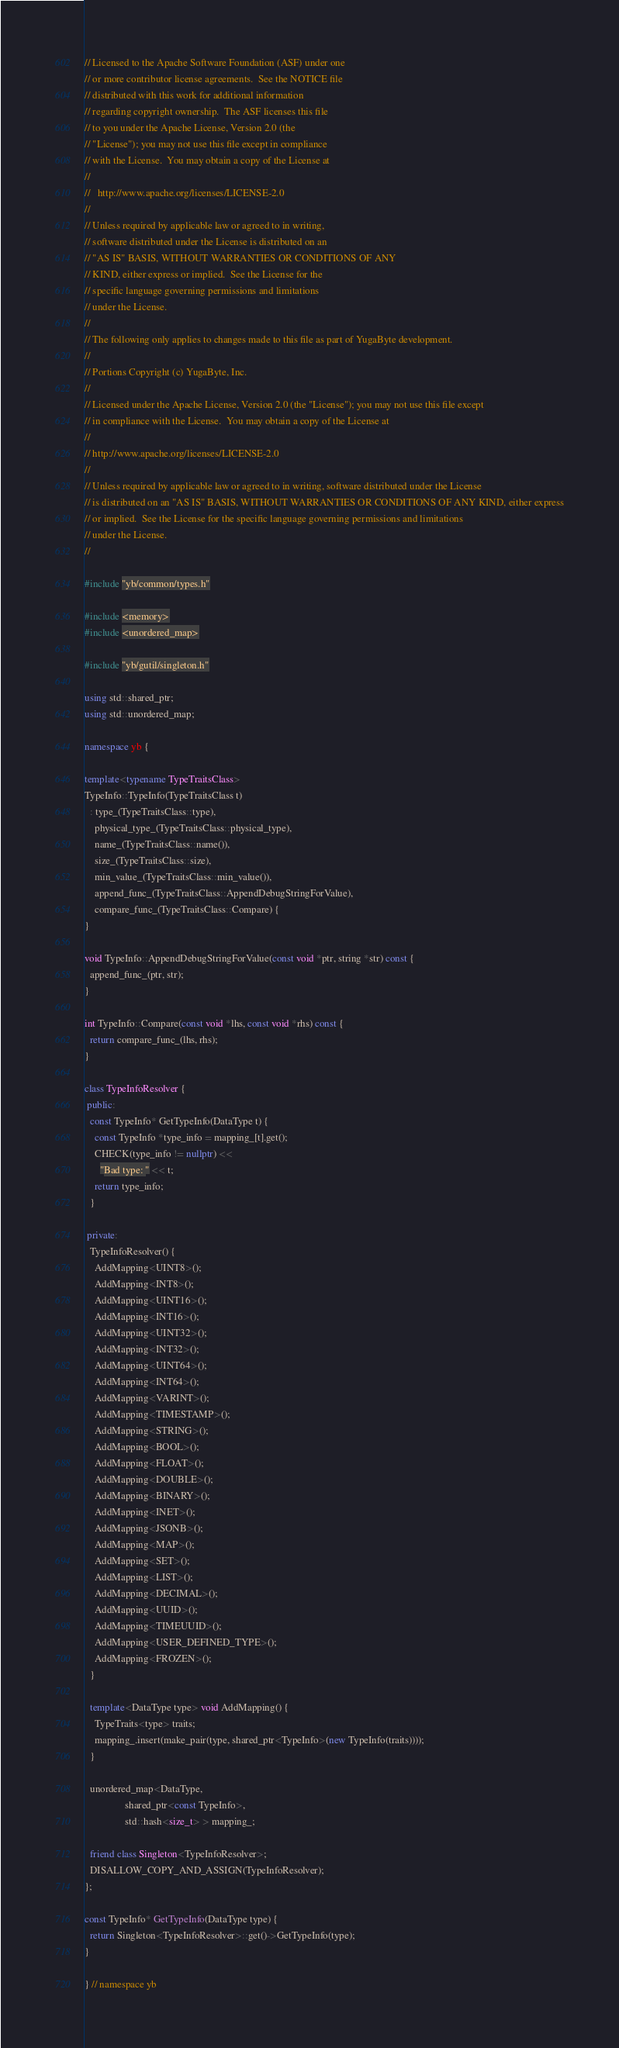<code> <loc_0><loc_0><loc_500><loc_500><_C++_>// Licensed to the Apache Software Foundation (ASF) under one
// or more contributor license agreements.  See the NOTICE file
// distributed with this work for additional information
// regarding copyright ownership.  The ASF licenses this file
// to you under the Apache License, Version 2.0 (the
// "License"); you may not use this file except in compliance
// with the License.  You may obtain a copy of the License at
//
//   http://www.apache.org/licenses/LICENSE-2.0
//
// Unless required by applicable law or agreed to in writing,
// software distributed under the License is distributed on an
// "AS IS" BASIS, WITHOUT WARRANTIES OR CONDITIONS OF ANY
// KIND, either express or implied.  See the License for the
// specific language governing permissions and limitations
// under the License.
//
// The following only applies to changes made to this file as part of YugaByte development.
//
// Portions Copyright (c) YugaByte, Inc.
//
// Licensed under the Apache License, Version 2.0 (the "License"); you may not use this file except
// in compliance with the License.  You may obtain a copy of the License at
//
// http://www.apache.org/licenses/LICENSE-2.0
//
// Unless required by applicable law or agreed to in writing, software distributed under the License
// is distributed on an "AS IS" BASIS, WITHOUT WARRANTIES OR CONDITIONS OF ANY KIND, either express
// or implied.  See the License for the specific language governing permissions and limitations
// under the License.
//

#include "yb/common/types.h"

#include <memory>
#include <unordered_map>

#include "yb/gutil/singleton.h"

using std::shared_ptr;
using std::unordered_map;

namespace yb {

template<typename TypeTraitsClass>
TypeInfo::TypeInfo(TypeTraitsClass t)
  : type_(TypeTraitsClass::type),
    physical_type_(TypeTraitsClass::physical_type),
    name_(TypeTraitsClass::name()),
    size_(TypeTraitsClass::size),
    min_value_(TypeTraitsClass::min_value()),
    append_func_(TypeTraitsClass::AppendDebugStringForValue),
    compare_func_(TypeTraitsClass::Compare) {
}

void TypeInfo::AppendDebugStringForValue(const void *ptr, string *str) const {
  append_func_(ptr, str);
}

int TypeInfo::Compare(const void *lhs, const void *rhs) const {
  return compare_func_(lhs, rhs);
}

class TypeInfoResolver {
 public:
  const TypeInfo* GetTypeInfo(DataType t) {
    const TypeInfo *type_info = mapping_[t].get();
    CHECK(type_info != nullptr) <<
      "Bad type: " << t;
    return type_info;
  }

 private:
  TypeInfoResolver() {
    AddMapping<UINT8>();
    AddMapping<INT8>();
    AddMapping<UINT16>();
    AddMapping<INT16>();
    AddMapping<UINT32>();
    AddMapping<INT32>();
    AddMapping<UINT64>();
    AddMapping<INT64>();
    AddMapping<VARINT>();
    AddMapping<TIMESTAMP>();
    AddMapping<STRING>();
    AddMapping<BOOL>();
    AddMapping<FLOAT>();
    AddMapping<DOUBLE>();
    AddMapping<BINARY>();
    AddMapping<INET>();
    AddMapping<JSONB>();
    AddMapping<MAP>();
    AddMapping<SET>();
    AddMapping<LIST>();
    AddMapping<DECIMAL>();
    AddMapping<UUID>();
    AddMapping<TIMEUUID>();
    AddMapping<USER_DEFINED_TYPE>();
    AddMapping<FROZEN>();
  }

  template<DataType type> void AddMapping() {
    TypeTraits<type> traits;
    mapping_.insert(make_pair(type, shared_ptr<TypeInfo>(new TypeInfo(traits))));
  }

  unordered_map<DataType,
                shared_ptr<const TypeInfo>,
                std::hash<size_t> > mapping_;

  friend class Singleton<TypeInfoResolver>;
  DISALLOW_COPY_AND_ASSIGN(TypeInfoResolver);
};

const TypeInfo* GetTypeInfo(DataType type) {
  return Singleton<TypeInfoResolver>::get()->GetTypeInfo(type);
}

} // namespace yb
</code> 